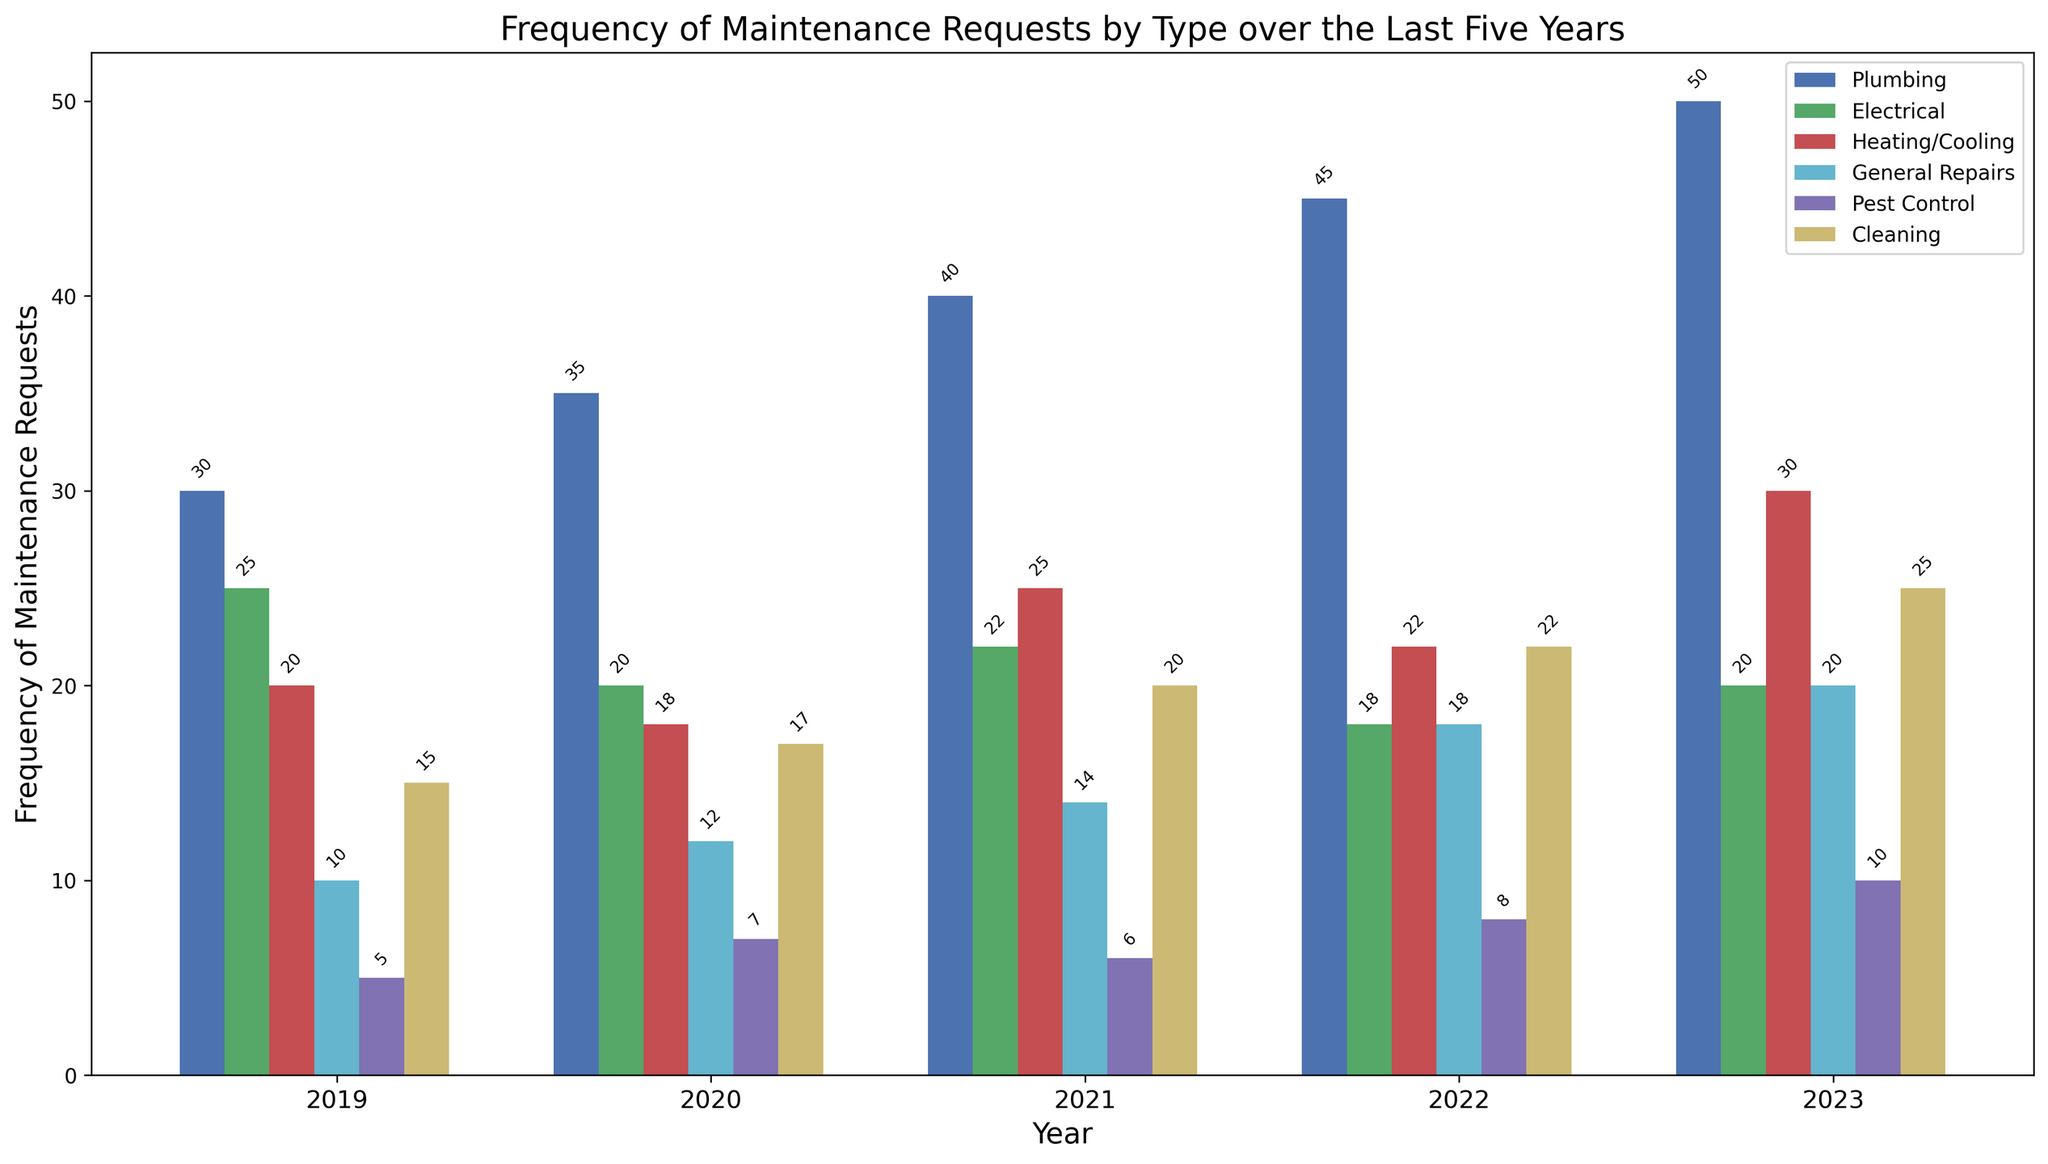What's the most frequently requested maintenance type in 2023? The figure shows the frequency of maintenance requests by type for each year. In 2023, comparing the heights of the bars, the "Plumbing" bar is the highest.
Answer: Plumbing Which type of maintenance has the shortest average response time over the entire period? The figure indicates the average response time for different maintenance types. Comparing the response times, "General Repairs" consistently has low values, especially in recent years.
Answer: General Repairs What is the total number of maintenance requests for Electrical and Heating/Cooling in 2021? To find the total number, locate the 2021 bars for Electrical (22) and Heating/Cooling (25) and sum them. 22 + 25 = 47
Answer: 47 In which year did Plumbing requests surpass 40 for the first time? Examining the heights of the Plumbing bars over the years, the first instance where the bar surpasses 40 requests is in 2021.
Answer: 2021 Compare the response times for Electrical between 2020 and 2022. Which year had a quicker response time? Comparing the average response time for Electrical in 2020 (2.1 days) and 2022 (2.5 days), 2020 had a quicker response.
Answer: 2020 How does the frequency of Pest Control requests in 2019 compare to those in 2023? Visual comparison shows that the bar for Pest Control in 2019 (5 requests) is half as tall as the bar in 2023 (10 requests).
Answer: The frequency in 2023 is double that of 2019 By how much did the frequency of General Repairs change from 2019 to 2023? The frequency of General Repairs in 2019 was 10, and by 2023, it increased to 20. The change can be calculated as 20 - 10 = 10.
Answer: Increased by 10 What's the average frequency of Cleaning requests during the five years? Sum the frequencies of Cleaning requests for each year (15, 17, 20, 22, 25) and divide by 5. (15 + 17 + 20 + 22 + 25) / 5 = 99 / 5 = 19.8
Answer: 19.8 Which type showed the most consistent response time across all years? Evaluating the stability of response times, General Repairs maintained relatively steady values around the 1 to 1.5 days range.
Answer: General Repairs In which year did the total number of maintenance requests reach its peak? Summing up the frequencies for each year and comparing, 2023 had the highest total requests.
Answer: 2023 